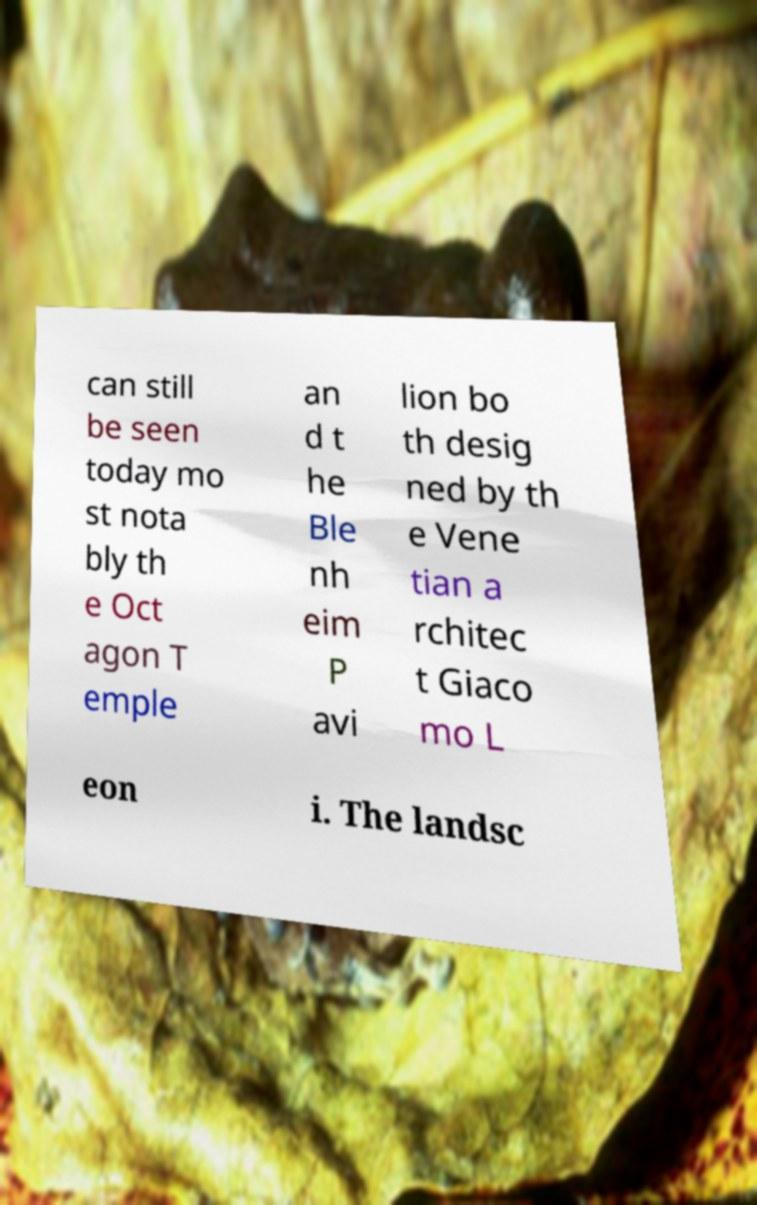Can you accurately transcribe the text from the provided image for me? can still be seen today mo st nota bly th e Oct agon T emple an d t he Ble nh eim P avi lion bo th desig ned by th e Vene tian a rchitec t Giaco mo L eon i. The landsc 